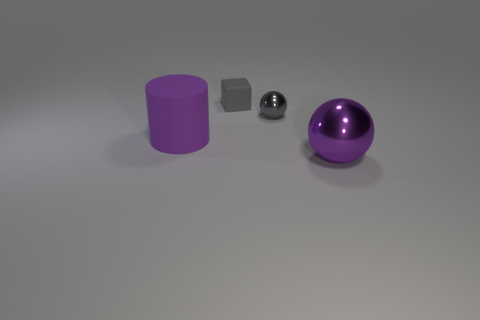Add 2 small rubber things. How many objects exist? 6 Subtract all cylinders. How many objects are left? 3 Add 4 metallic things. How many metallic things exist? 6 Subtract 0 brown cylinders. How many objects are left? 4 Subtract all tiny brown shiny balls. Subtract all big purple rubber cylinders. How many objects are left? 3 Add 1 large metallic spheres. How many large metallic spheres are left? 2 